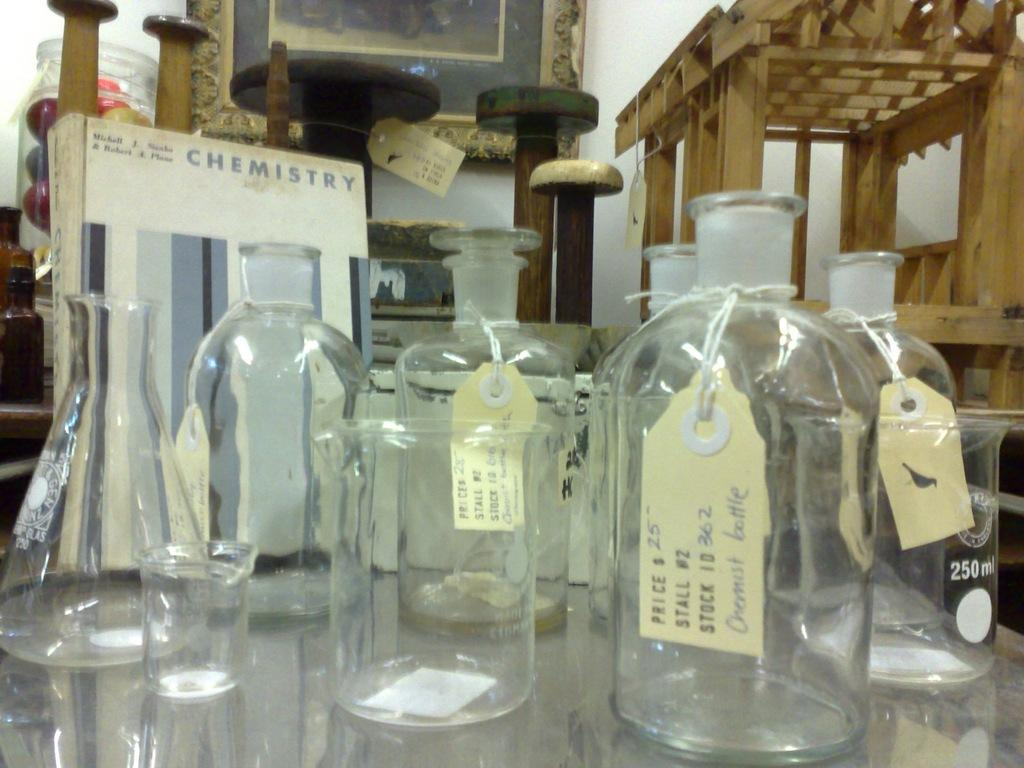<image>
Summarize the visual content of the image. Glass bottles with price tags are displayed and the front bottle is priced a $25.00. 